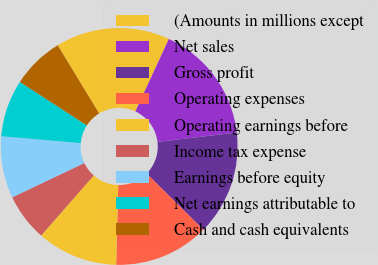Convert chart. <chart><loc_0><loc_0><loc_500><loc_500><pie_chart><fcel>(Amounts in millions except<fcel>Net sales<fcel>Gross profit<fcel>Operating expenses<fcel>Operating earnings before<fcel>Income tax expense<fcel>Earnings before equity<fcel>Net earnings attributable to<fcel>Cash and cash equivalents<nl><fcel>15.58%<fcel>16.23%<fcel>14.29%<fcel>12.99%<fcel>11.04%<fcel>6.49%<fcel>8.44%<fcel>7.79%<fcel>7.14%<nl></chart> 